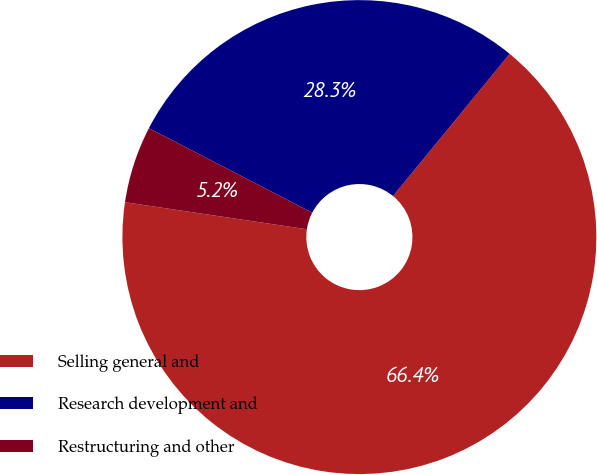Convert chart to OTSL. <chart><loc_0><loc_0><loc_500><loc_500><pie_chart><fcel>Selling general and<fcel>Research development and<fcel>Restructuring and other<nl><fcel>66.42%<fcel>28.33%<fcel>5.25%<nl></chart> 